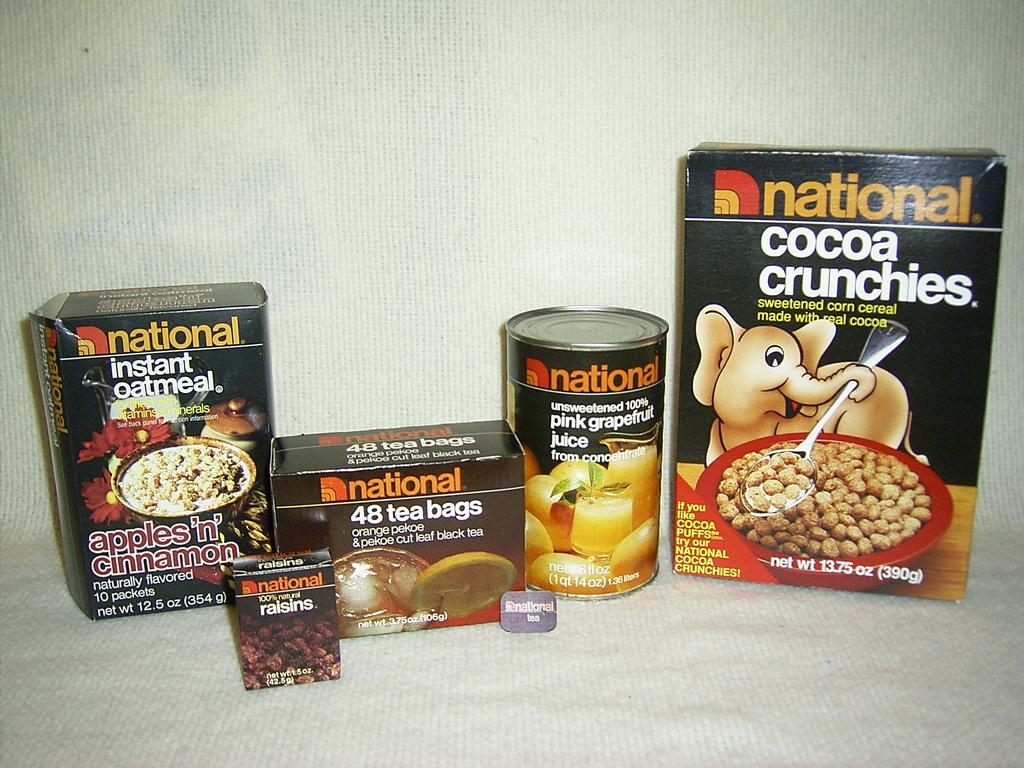What is the main subject of the image? The main subject of the image is food items packed in boxes. Can you describe any additional elements in the image? Yes, there is an image of an elephant holding a spoon on the right side of the image. How does the elephant contribute to the digestion of the food in the image? The elephant is not a real animal in the image, but rather a drawing or illustration, and therefore does not contribute to the digestion of the food. 